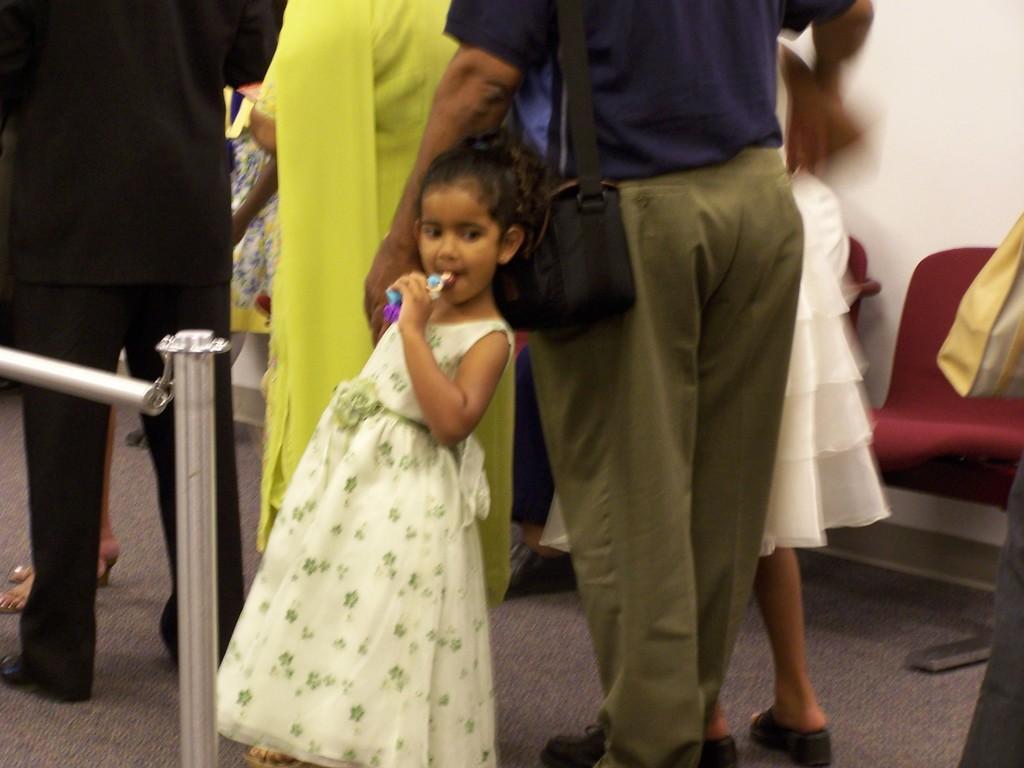Describe this image in one or two sentences. In this image we can see people. In the center there is a girl standing and holding an object. On the left there is a railing. In the background there are chairs and a wall. 